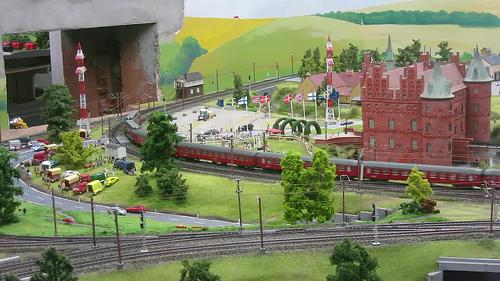Question: when was this photo taken?
Choices:
A. At dawn.
B. At midnight.
C. During the day.
D. In the evening.
Answer with the letter. Answer: C Question: what animals are on the left middle of the photo?
Choices:
A. Horses.
B. Bears.
C. Pigs.
D. Wolves.
Answer with the letter. Answer: A Question: how many red and white towers are there?
Choices:
A. 1.
B. 3.
C. 5.
D. 2.
Answer with the letter. Answer: D 